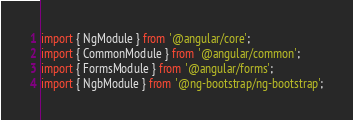<code> <loc_0><loc_0><loc_500><loc_500><_TypeScript_>import { NgModule } from '@angular/core';
import { CommonModule } from '@angular/common';
import { FormsModule } from '@angular/forms';
import { NgbModule } from '@ng-bootstrap/ng-bootstrap';
</code> 